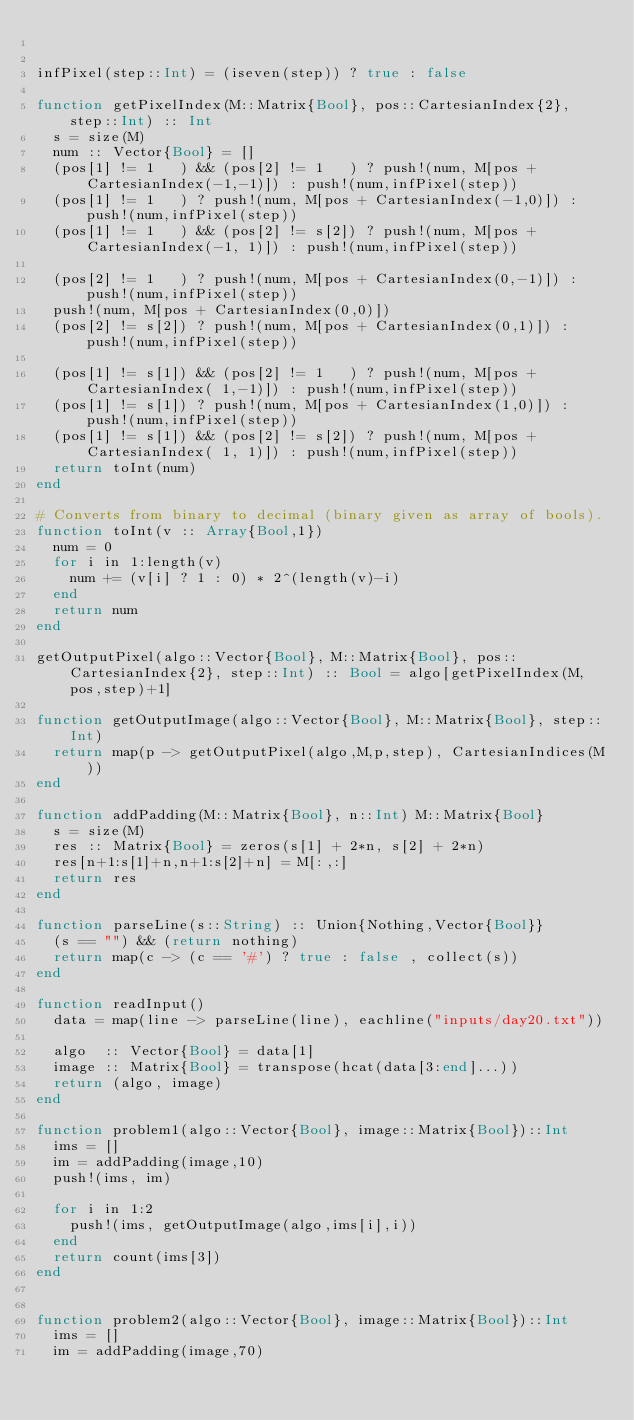Convert code to text. <code><loc_0><loc_0><loc_500><loc_500><_Julia_>

infPixel(step::Int) = (iseven(step)) ? true : false

function getPixelIndex(M::Matrix{Bool}, pos::CartesianIndex{2}, step::Int) :: Int
  s = size(M)
  num :: Vector{Bool} = []
  (pos[1] != 1   ) && (pos[2] != 1   ) ? push!(num, M[pos + CartesianIndex(-1,-1)]) : push!(num,infPixel(step))
  (pos[1] != 1   ) ? push!(num, M[pos + CartesianIndex(-1,0)]) : push!(num,infPixel(step))
  (pos[1] != 1   ) && (pos[2] != s[2]) ? push!(num, M[pos + CartesianIndex(-1, 1)]) : push!(num,infPixel(step))

  (pos[2] != 1   ) ? push!(num, M[pos + CartesianIndex(0,-1)]) : push!(num,infPixel(step))
  push!(num, M[pos + CartesianIndex(0,0)])
  (pos[2] != s[2]) ? push!(num, M[pos + CartesianIndex(0,1)]) : push!(num,infPixel(step))

  (pos[1] != s[1]) && (pos[2] != 1   ) ? push!(num, M[pos + CartesianIndex( 1,-1)]) : push!(num,infPixel(step))
  (pos[1] != s[1]) ? push!(num, M[pos + CartesianIndex(1,0)]) : push!(num,infPixel(step))
  (pos[1] != s[1]) && (pos[2] != s[2]) ? push!(num, M[pos + CartesianIndex( 1, 1)]) : push!(num,infPixel(step))
  return toInt(num)
end

# Converts from binary to decimal (binary given as array of bools). 
function toInt(v :: Array{Bool,1}) 
  num = 0
  for i in 1:length(v)
    num += (v[i] ? 1 : 0) * 2^(length(v)-i)
  end
  return num
end

getOutputPixel(algo::Vector{Bool}, M::Matrix{Bool}, pos::CartesianIndex{2}, step::Int) :: Bool = algo[getPixelIndex(M,pos,step)+1]

function getOutputImage(algo::Vector{Bool}, M::Matrix{Bool}, step::Int)
  return map(p -> getOutputPixel(algo,M,p,step), CartesianIndices(M))
end

function addPadding(M::Matrix{Bool}, n::Int) M::Matrix{Bool}
  s = size(M)
  res :: Matrix{Bool} = zeros(s[1] + 2*n, s[2] + 2*n)
  res[n+1:s[1]+n,n+1:s[2]+n] = M[:,:]
  return res 
end

function parseLine(s::String) :: Union{Nothing,Vector{Bool}}
  (s == "") && (return nothing)
  return map(c -> (c == '#') ? true : false , collect(s))
end

function readInput()
  data = map(line -> parseLine(line), eachline("inputs/day20.txt"))

  algo  :: Vector{Bool} = data[1]
  image :: Matrix{Bool} = transpose(hcat(data[3:end]...))
  return (algo, image)
end

function problem1(algo::Vector{Bool}, image::Matrix{Bool})::Int
  ims = []
  im = addPadding(image,10)
  push!(ims, im)

  for i in 1:2
    push!(ims, getOutputImage(algo,ims[i],i))
  end
  return count(ims[3])
end


function problem2(algo::Vector{Bool}, image::Matrix{Bool})::Int
  ims = []
  im = addPadding(image,70)</code> 